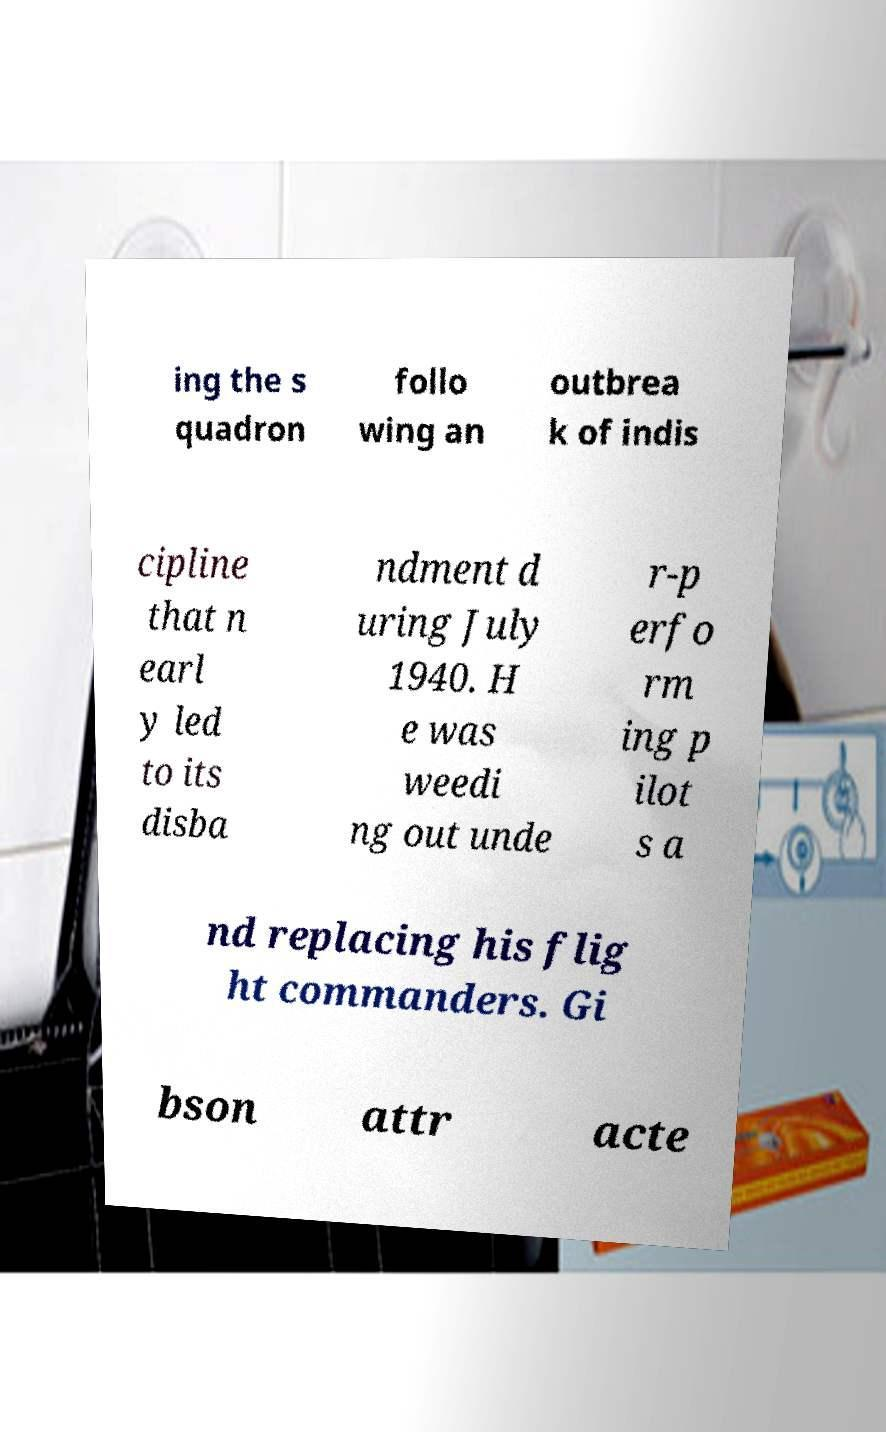What messages or text are displayed in this image? I need them in a readable, typed format. ing the s quadron follo wing an outbrea k of indis cipline that n earl y led to its disba ndment d uring July 1940. H e was weedi ng out unde r-p erfo rm ing p ilot s a nd replacing his flig ht commanders. Gi bson attr acte 